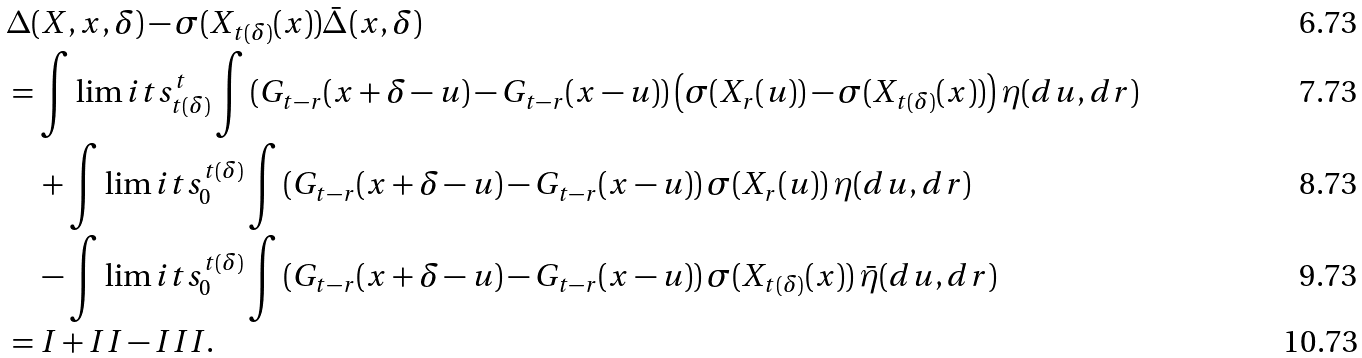Convert formula to latex. <formula><loc_0><loc_0><loc_500><loc_500>& \Delta ( X , x , \delta ) - \sigma ( X _ { t ( \delta ) } ( x ) ) \bar { \Delta } ( x , \delta ) \\ & = \int \lim i t s ^ { t } _ { t ( \delta ) } \int \left ( G _ { t - r } ( x + \delta - u ) - G _ { t - r } ( x - u ) \right ) \left ( \sigma ( X _ { r } ( u ) ) - \sigma ( X _ { t ( \delta ) } ( x ) ) \right ) \eta ( d u , d r ) \\ & \quad + \int \lim i t s ^ { t ( \delta ) } _ { 0 } \int \left ( G _ { t - r } ( x + \delta - u ) - G _ { t - r } ( x - u ) \right ) \sigma ( X _ { r } ( u ) ) \, \eta ( d u , d r ) \\ & \quad - \int \lim i t s ^ { t ( \delta ) } _ { 0 } \int \left ( G _ { t - r } ( x + \delta - u ) - G _ { t - r } ( x - u ) \right ) \sigma ( X _ { t ( \delta ) } ( x ) ) \, \bar { \eta } ( d u , d r ) \\ & = I + I I - I I I .</formula> 